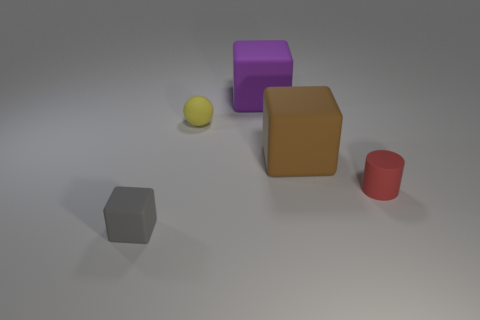How many objects are either big cubes in front of the large purple matte block or small yellow rubber things?
Give a very brief answer. 2. Are the red cylinder and the big cube that is behind the brown block made of the same material?
Provide a short and direct response. Yes. What shape is the gray rubber object that is to the left of the tiny matte thing behind the tiny red object?
Offer a very short reply. Cube. Does the rubber ball have the same color as the small object on the left side of the tiny yellow sphere?
Ensure brevity in your answer.  No. Are there any other things that have the same material as the tiny block?
Your response must be concise. Yes. There is a tiny yellow thing; what shape is it?
Provide a short and direct response. Sphere. There is a purple thing right of the small rubber thing behind the red rubber thing; how big is it?
Your response must be concise. Large. Are there an equal number of tiny spheres that are left of the gray thing and big brown cubes that are to the right of the red object?
Your response must be concise. Yes. There is a object that is to the right of the purple rubber thing and left of the tiny red thing; what is its material?
Ensure brevity in your answer.  Rubber. There is a purple thing; is its size the same as the rubber cube in front of the cylinder?
Your answer should be compact. No. 